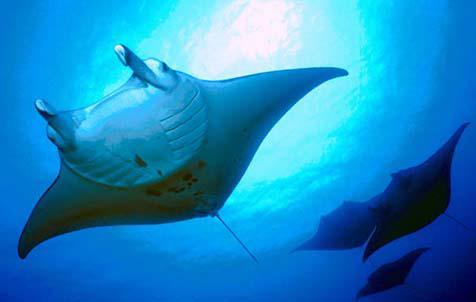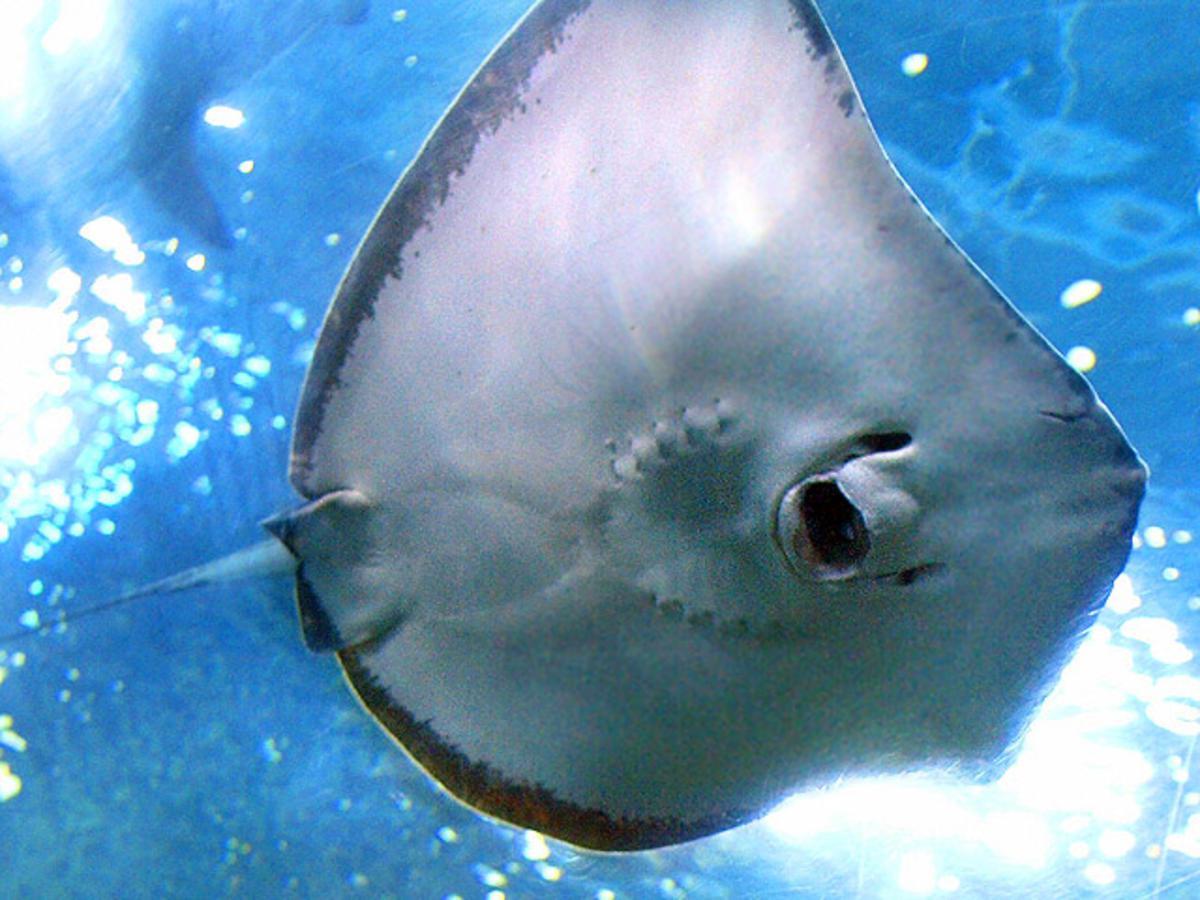The first image is the image on the left, the second image is the image on the right. Examine the images to the left and right. Is the description "The right image shows the complete underbelly of a manta ray." accurate? Answer yes or no. Yes. 